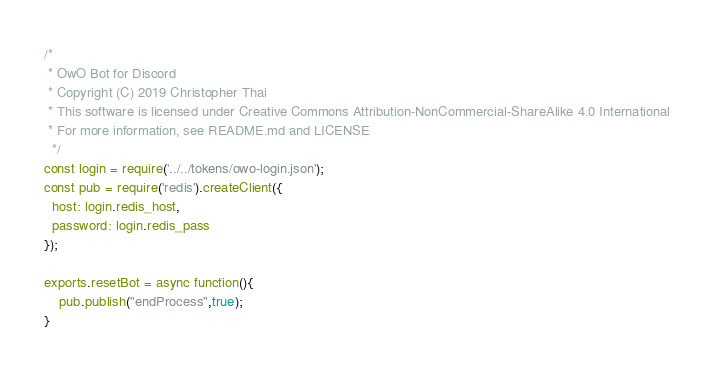Convert code to text. <code><loc_0><loc_0><loc_500><loc_500><_JavaScript_>/*
 * OwO Bot for Discord
 * Copyright (C) 2019 Christopher Thai
 * This software is licensed under Creative Commons Attribution-NonCommercial-ShareAlike 4.0 International
 * For more information, see README.md and LICENSE
  */
const login = require('../../tokens/owo-login.json');
const pub = require('redis').createClient({
  host: login.redis_host,
  password: login.redis_pass
});
	
exports.resetBot = async function(){
	pub.publish("endProcess",true);
}
</code> 